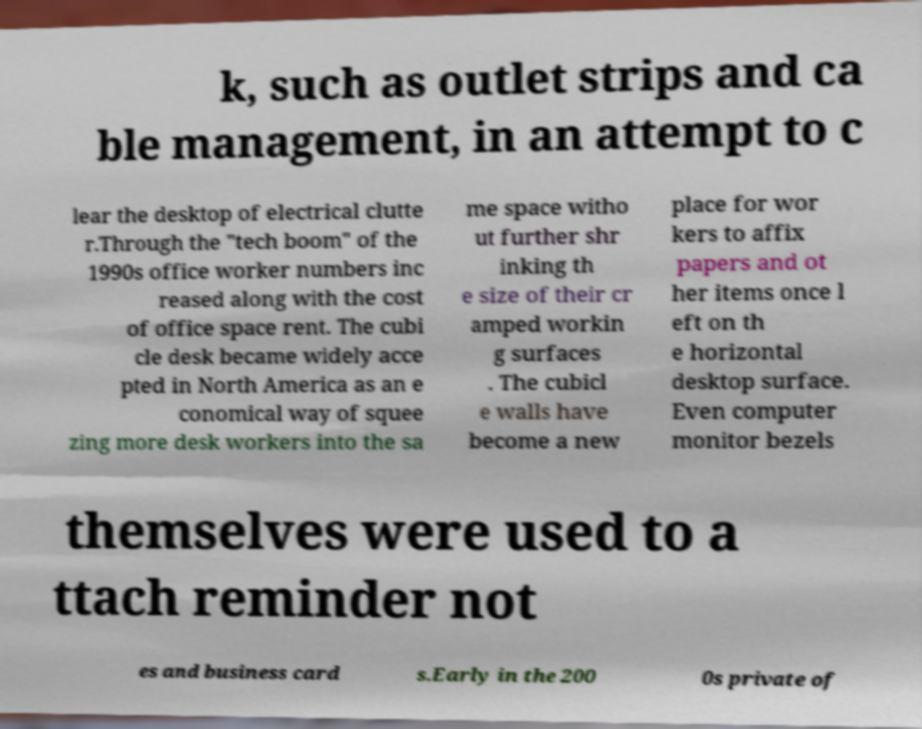Could you assist in decoding the text presented in this image and type it out clearly? k, such as outlet strips and ca ble management, in an attempt to c lear the desktop of electrical clutte r.Through the "tech boom" of the 1990s office worker numbers inc reased along with the cost of office space rent. The cubi cle desk became widely acce pted in North America as an e conomical way of squee zing more desk workers into the sa me space witho ut further shr inking th e size of their cr amped workin g surfaces . The cubicl e walls have become a new place for wor kers to affix papers and ot her items once l eft on th e horizontal desktop surface. Even computer monitor bezels themselves were used to a ttach reminder not es and business card s.Early in the 200 0s private of 